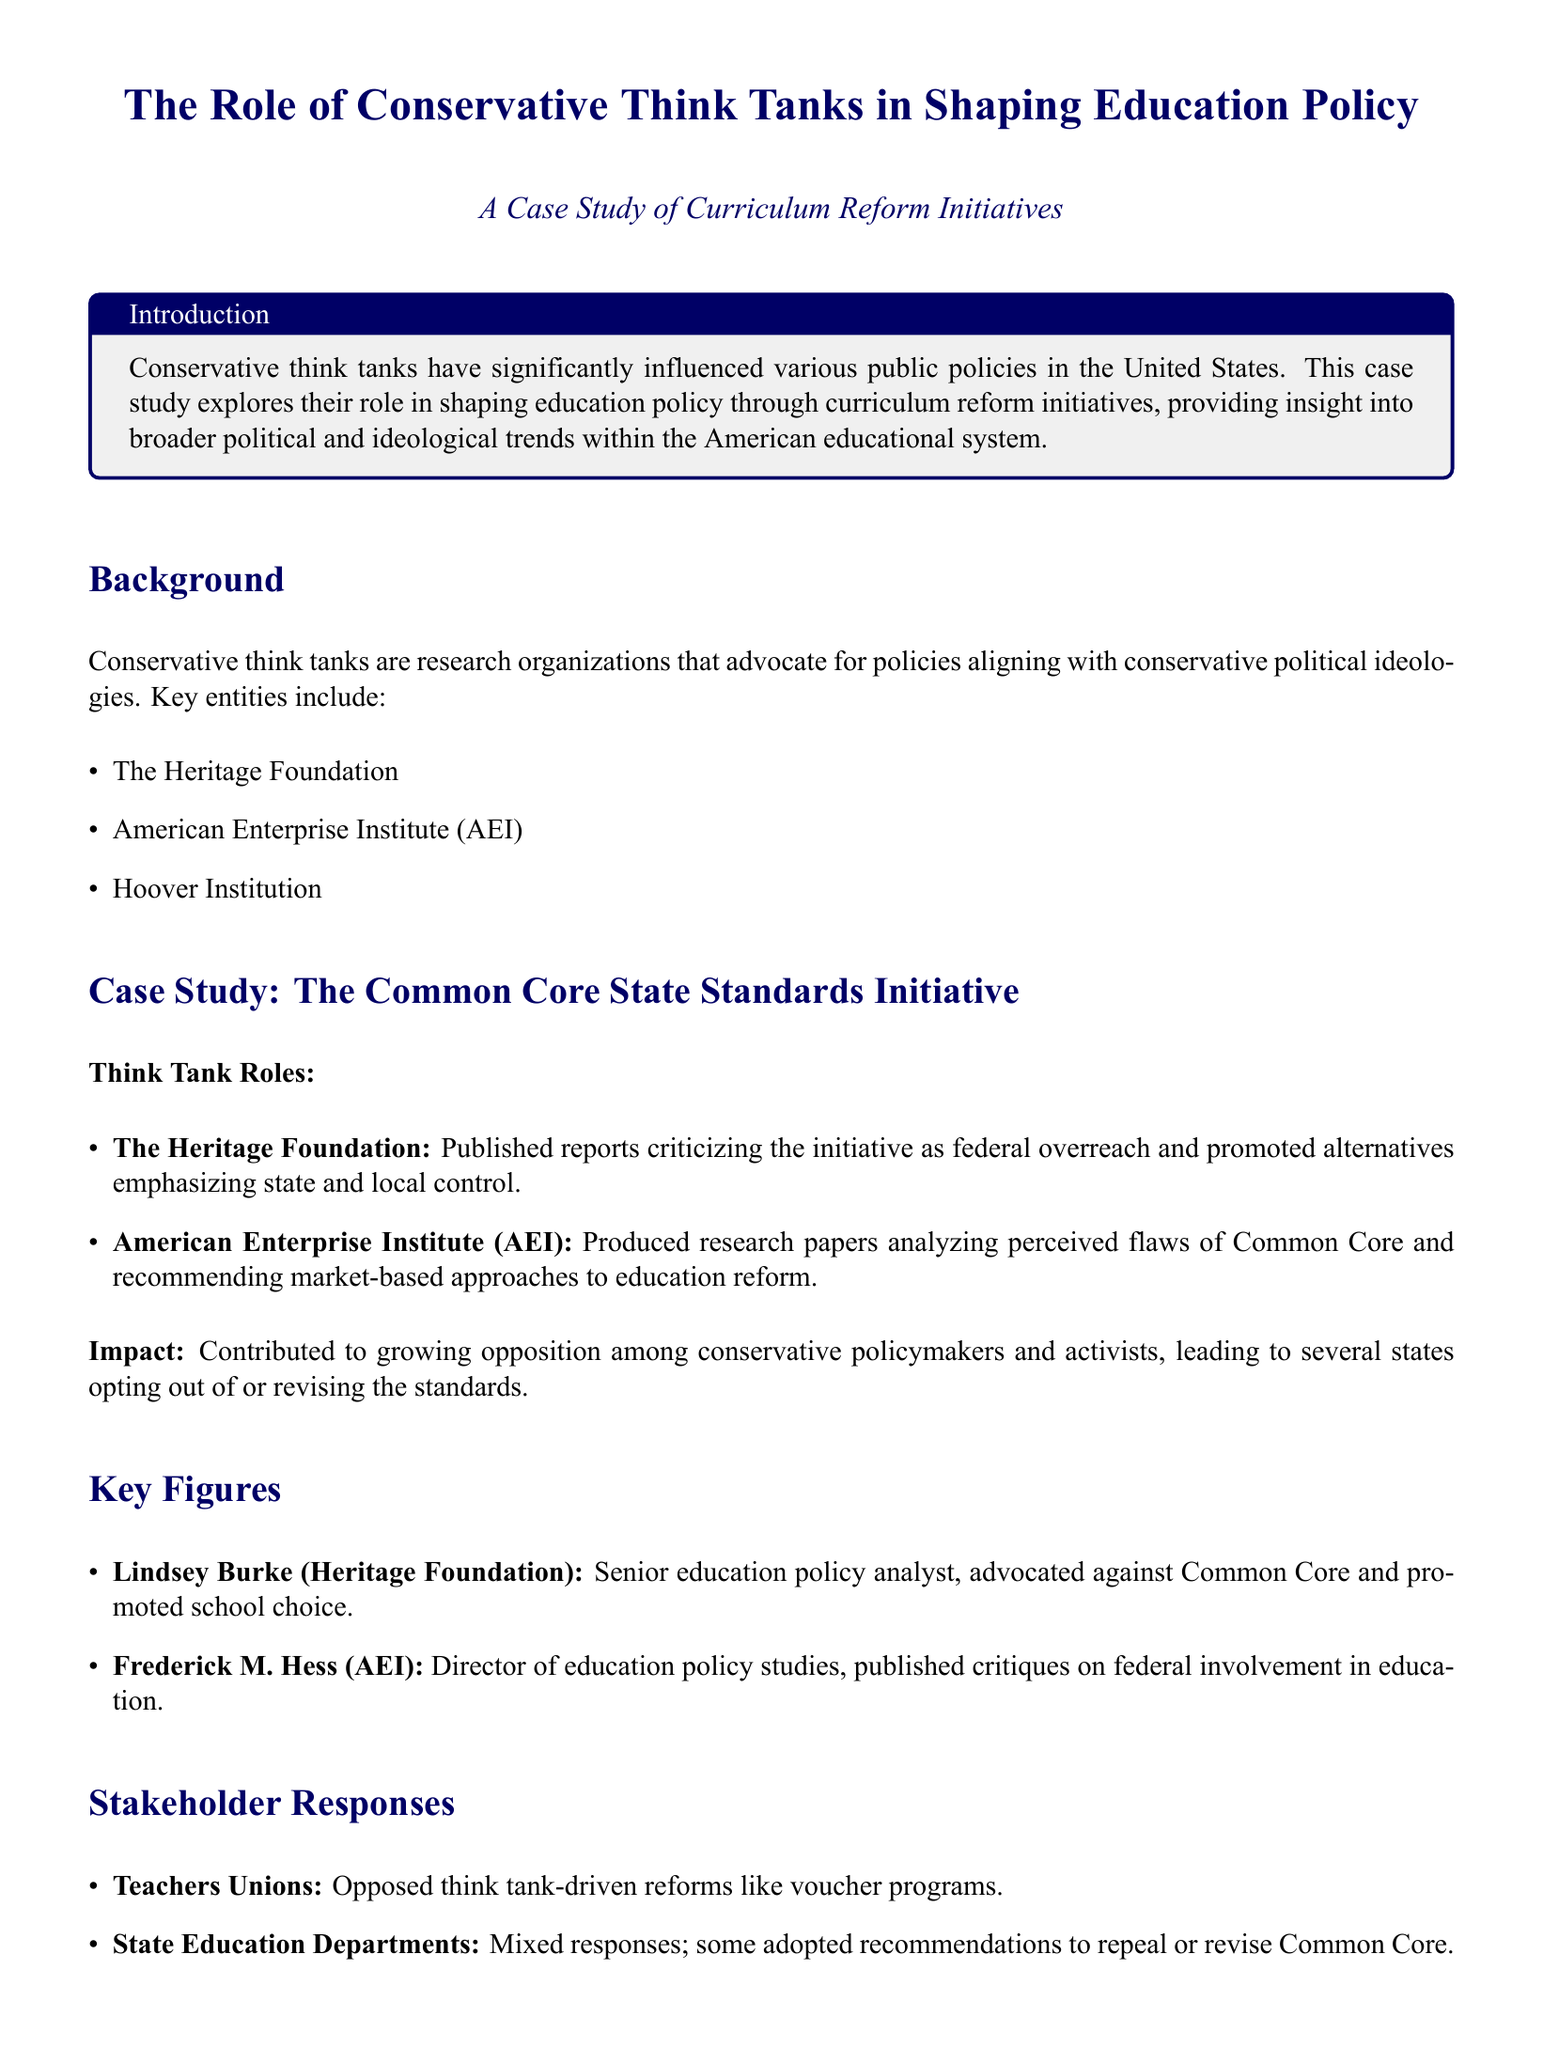What are key conservative think tanks mentioned? The document lists several conservative think tanks, highlighting their influence on education policy.
Answer: The Heritage Foundation, American Enterprise Institute, Hoover Institution Who is a senior education policy analyst at the Heritage Foundation? The document identifies a key figure associated with the Heritage Foundation who focuses on education policy.
Answer: Lindsey Burke What initiative is the case study focused on? The document specifies the educational initiative that serves as the case study for the impact of conservative think tanks.
Answer: The Common Core State Standards Initiative What approach did AEI recommend for education reform? The document notes the solutions proposed by AEI to address issues with the Common Core.
Answer: Market-based approaches Which stakeholder opposed voucher programs? The document mentions organizations that had contrasting views regarding the policies promoted by conservative think tanks.
Answer: Teachers Unions What was a significant consequence of think tank influence on Common Core? The document explains the outcomes stemming from the efforts of conservative think tanks on this educational initiative.
Answer: States opting out or revising the standards What is a key theme in the discussion section? The discussion section outlines the main focus areas championed by conservative think tanks in their policy advocacy.
Answer: Decentralization, school choice, and privatization What type of research did the Heritage Foundation conduct on Common Core? The document describes the type of reports produced by the Heritage Foundation regarding the Common Core initiative.
Answer: Published reports criticizing federal overreach 